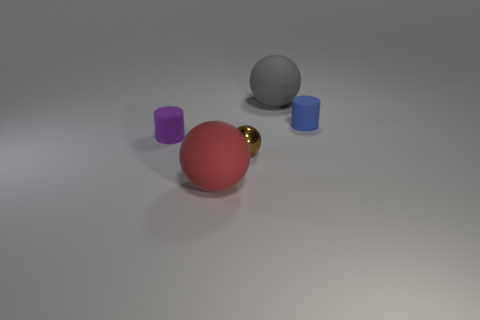There is a brown metallic ball; is it the same size as the matte ball that is behind the blue matte cylinder?
Keep it short and to the point. No. What number of yellow metal balls have the same size as the blue object?
Your answer should be very brief. 0. What color is the other cylinder that is the same material as the small blue cylinder?
Your response must be concise. Purple. Are there more purple objects than large blue matte spheres?
Provide a short and direct response. Yes. Is the tiny blue object made of the same material as the big red sphere?
Your answer should be very brief. Yes. There is a red thing that is the same material as the tiny purple thing; what shape is it?
Your answer should be compact. Sphere. Are there fewer big gray rubber things than yellow metallic cubes?
Keep it short and to the point. No. There is a thing that is to the left of the brown shiny sphere and behind the large red sphere; what is it made of?
Your answer should be very brief. Rubber. What size is the matte cylinder that is on the left side of the blue matte thing that is to the right of the tiny cylinder in front of the small blue thing?
Provide a succinct answer. Small. Is the shape of the tiny purple thing the same as the large rubber object in front of the small brown sphere?
Your answer should be very brief. No. 